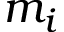<formula> <loc_0><loc_0><loc_500><loc_500>m _ { i }</formula> 